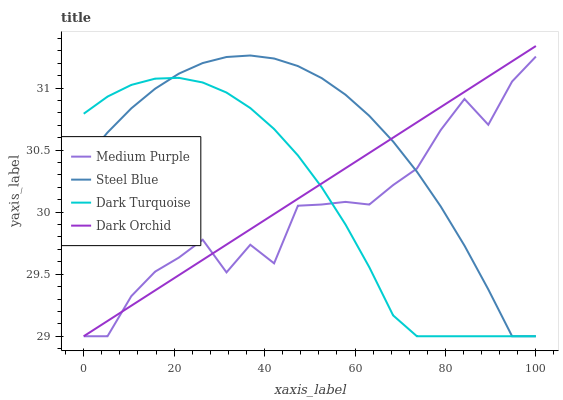Does Medium Purple have the minimum area under the curve?
Answer yes or no. Yes. Does Steel Blue have the maximum area under the curve?
Answer yes or no. Yes. Does Dark Turquoise have the minimum area under the curve?
Answer yes or no. No. Does Dark Turquoise have the maximum area under the curve?
Answer yes or no. No. Is Dark Orchid the smoothest?
Answer yes or no. Yes. Is Medium Purple the roughest?
Answer yes or no. Yes. Is Dark Turquoise the smoothest?
Answer yes or no. No. Is Dark Turquoise the roughest?
Answer yes or no. No. Does Steel Blue have the highest value?
Answer yes or no. No. 